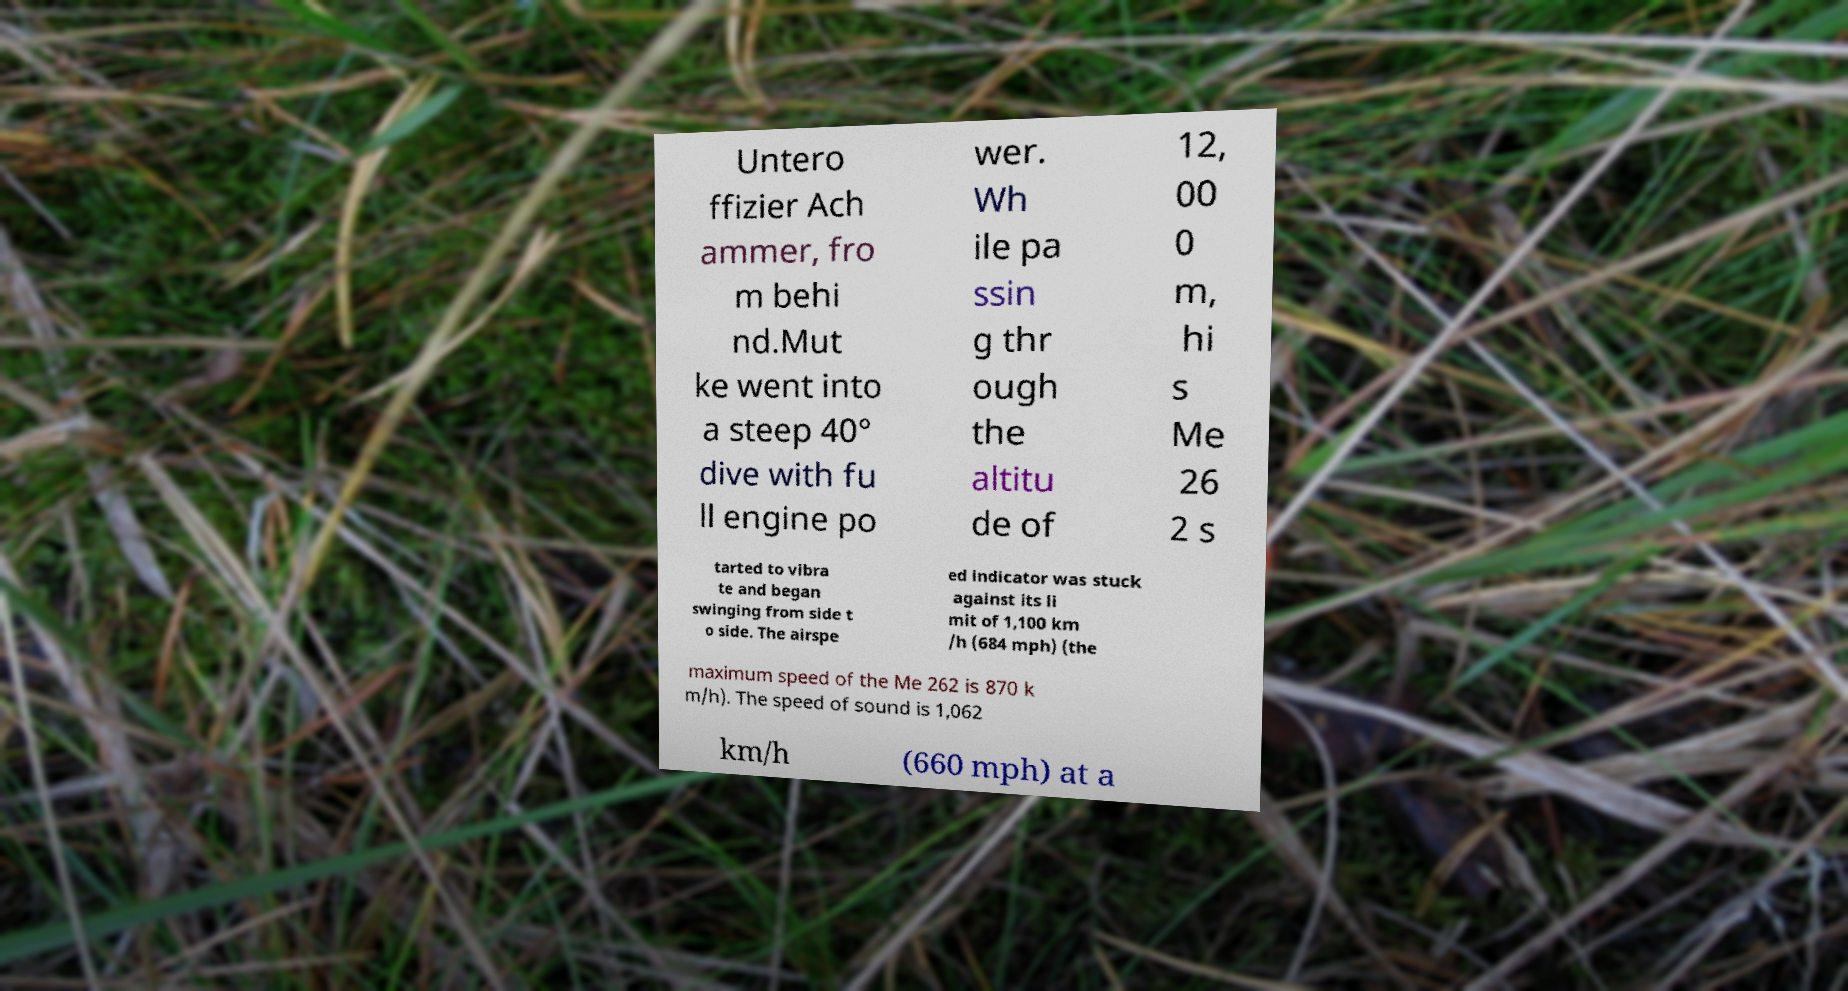I need the written content from this picture converted into text. Can you do that? Untero ffizier Ach ammer, fro m behi nd.Mut ke went into a steep 40° dive with fu ll engine po wer. Wh ile pa ssin g thr ough the altitu de of 12, 00 0 m, hi s Me 26 2 s tarted to vibra te and began swinging from side t o side. The airspe ed indicator was stuck against its li mit of 1,100 km /h (684 mph) (the maximum speed of the Me 262 is 870 k m/h). The speed of sound is 1,062 km/h (660 mph) at a 